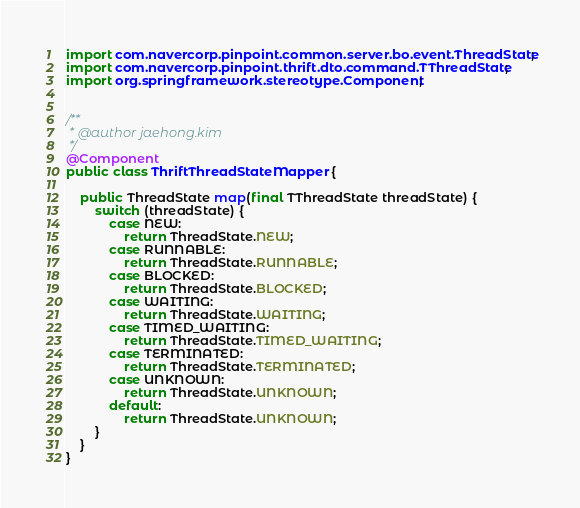<code> <loc_0><loc_0><loc_500><loc_500><_Java_>
import com.navercorp.pinpoint.common.server.bo.event.ThreadState;
import com.navercorp.pinpoint.thrift.dto.command.TThreadState;
import org.springframework.stereotype.Component;


/**
 * @author jaehong.kim
 */
@Component
public class ThriftThreadStateMapper {

    public ThreadState map(final TThreadState threadState) {
        switch (threadState) {
            case NEW:
                return ThreadState.NEW;
            case RUNNABLE:
                return ThreadState.RUNNABLE;
            case BLOCKED:
                return ThreadState.BLOCKED;
            case WAITING:
                return ThreadState.WAITING;
            case TIMED_WAITING:
                return ThreadState.TIMED_WAITING;
            case TERMINATED:
                return ThreadState.TERMINATED;
            case UNKNOWN:
                return ThreadState.UNKNOWN;
            default:
                return ThreadState.UNKNOWN;
        }
    }
}</code> 